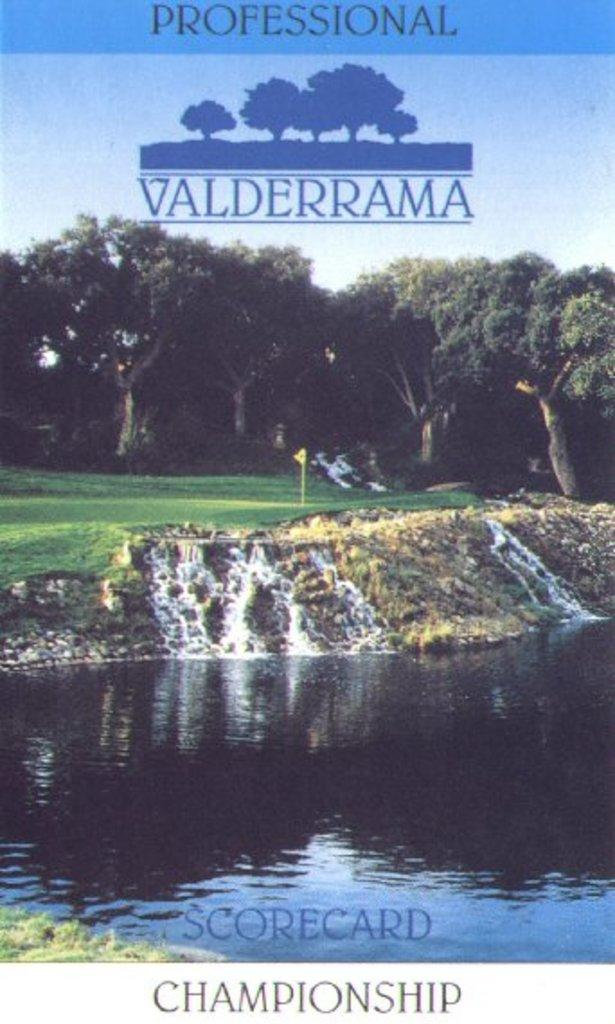<image>
Summarize the visual content of the image. A scorecard, from the Valderrama course, has a photo of a hole with a water trap. 